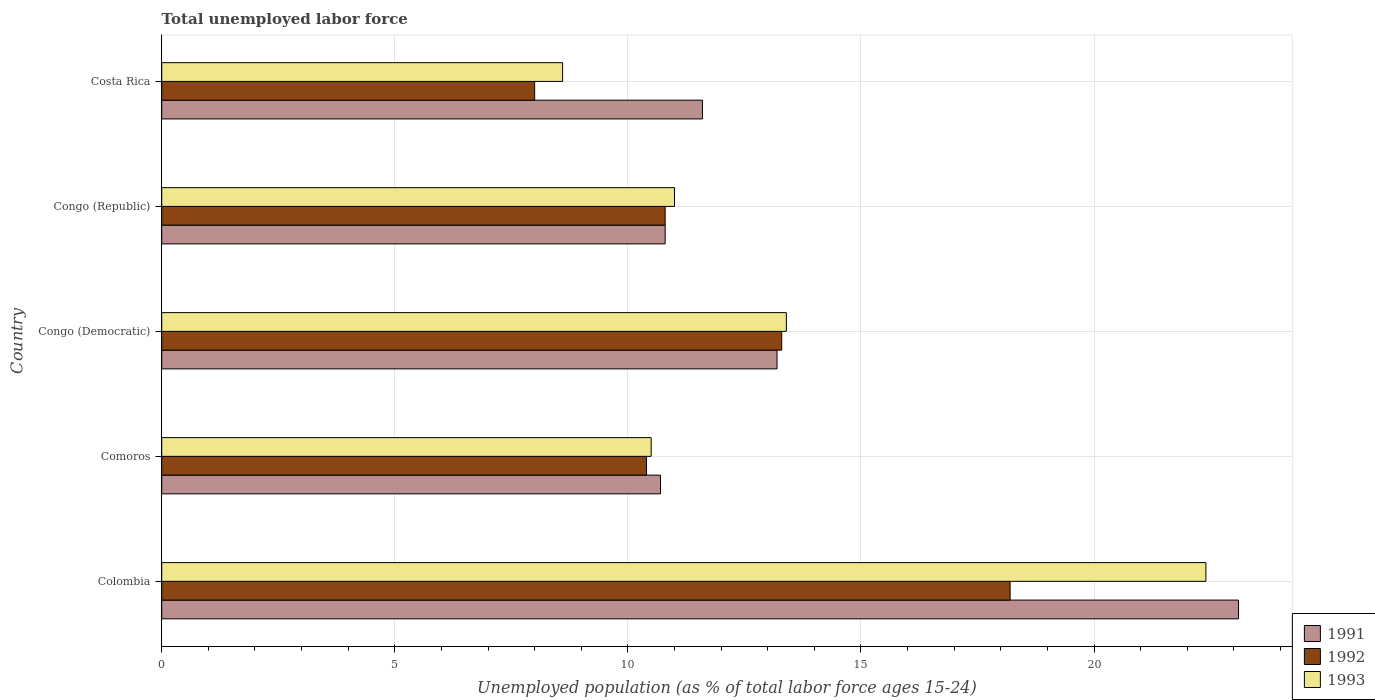How many bars are there on the 4th tick from the top?
Offer a very short reply. 3. How many bars are there on the 5th tick from the bottom?
Offer a very short reply. 3. What is the label of the 4th group of bars from the top?
Make the answer very short. Comoros. In how many cases, is the number of bars for a given country not equal to the number of legend labels?
Keep it short and to the point. 0. What is the percentage of unemployed population in in 1992 in Congo (Democratic)?
Offer a very short reply. 13.3. Across all countries, what is the maximum percentage of unemployed population in in 1992?
Your answer should be very brief. 18.2. In which country was the percentage of unemployed population in in 1991 maximum?
Keep it short and to the point. Colombia. What is the total percentage of unemployed population in in 1992 in the graph?
Make the answer very short. 60.7. What is the difference between the percentage of unemployed population in in 1992 in Congo (Democratic) and that in Congo (Republic)?
Your answer should be very brief. 2.5. What is the difference between the percentage of unemployed population in in 1992 in Comoros and the percentage of unemployed population in in 1991 in Costa Rica?
Offer a very short reply. -1.2. What is the average percentage of unemployed population in in 1991 per country?
Make the answer very short. 13.88. What is the difference between the percentage of unemployed population in in 1993 and percentage of unemployed population in in 1991 in Congo (Republic)?
Give a very brief answer. 0.2. In how many countries, is the percentage of unemployed population in in 1992 greater than 10 %?
Your answer should be very brief. 4. What is the ratio of the percentage of unemployed population in in 1992 in Congo (Democratic) to that in Congo (Republic)?
Keep it short and to the point. 1.23. What is the difference between the highest and the second highest percentage of unemployed population in in 1992?
Offer a very short reply. 4.9. What is the difference between the highest and the lowest percentage of unemployed population in in 1993?
Provide a succinct answer. 13.8. In how many countries, is the percentage of unemployed population in in 1991 greater than the average percentage of unemployed population in in 1991 taken over all countries?
Give a very brief answer. 1. What does the 2nd bar from the bottom in Congo (Democratic) represents?
Give a very brief answer. 1992. Is it the case that in every country, the sum of the percentage of unemployed population in in 1991 and percentage of unemployed population in in 1993 is greater than the percentage of unemployed population in in 1992?
Offer a very short reply. Yes. How many countries are there in the graph?
Provide a short and direct response. 5. Does the graph contain any zero values?
Make the answer very short. No. Does the graph contain grids?
Make the answer very short. Yes. Where does the legend appear in the graph?
Your answer should be very brief. Bottom right. How many legend labels are there?
Your response must be concise. 3. How are the legend labels stacked?
Your answer should be very brief. Vertical. What is the title of the graph?
Give a very brief answer. Total unemployed labor force. What is the label or title of the X-axis?
Provide a short and direct response. Unemployed population (as % of total labor force ages 15-24). What is the label or title of the Y-axis?
Keep it short and to the point. Country. What is the Unemployed population (as % of total labor force ages 15-24) of 1991 in Colombia?
Offer a very short reply. 23.1. What is the Unemployed population (as % of total labor force ages 15-24) in 1992 in Colombia?
Keep it short and to the point. 18.2. What is the Unemployed population (as % of total labor force ages 15-24) of 1993 in Colombia?
Provide a short and direct response. 22.4. What is the Unemployed population (as % of total labor force ages 15-24) in 1991 in Comoros?
Provide a short and direct response. 10.7. What is the Unemployed population (as % of total labor force ages 15-24) in 1992 in Comoros?
Your answer should be very brief. 10.4. What is the Unemployed population (as % of total labor force ages 15-24) in 1993 in Comoros?
Make the answer very short. 10.5. What is the Unemployed population (as % of total labor force ages 15-24) in 1991 in Congo (Democratic)?
Keep it short and to the point. 13.2. What is the Unemployed population (as % of total labor force ages 15-24) of 1992 in Congo (Democratic)?
Offer a very short reply. 13.3. What is the Unemployed population (as % of total labor force ages 15-24) of 1993 in Congo (Democratic)?
Your response must be concise. 13.4. What is the Unemployed population (as % of total labor force ages 15-24) of 1991 in Congo (Republic)?
Make the answer very short. 10.8. What is the Unemployed population (as % of total labor force ages 15-24) in 1992 in Congo (Republic)?
Give a very brief answer. 10.8. What is the Unemployed population (as % of total labor force ages 15-24) in 1991 in Costa Rica?
Your answer should be compact. 11.6. What is the Unemployed population (as % of total labor force ages 15-24) in 1992 in Costa Rica?
Keep it short and to the point. 8. What is the Unemployed population (as % of total labor force ages 15-24) in 1993 in Costa Rica?
Give a very brief answer. 8.6. Across all countries, what is the maximum Unemployed population (as % of total labor force ages 15-24) in 1991?
Your answer should be very brief. 23.1. Across all countries, what is the maximum Unemployed population (as % of total labor force ages 15-24) in 1992?
Ensure brevity in your answer.  18.2. Across all countries, what is the maximum Unemployed population (as % of total labor force ages 15-24) in 1993?
Offer a very short reply. 22.4. Across all countries, what is the minimum Unemployed population (as % of total labor force ages 15-24) of 1991?
Your answer should be very brief. 10.7. Across all countries, what is the minimum Unemployed population (as % of total labor force ages 15-24) in 1993?
Provide a succinct answer. 8.6. What is the total Unemployed population (as % of total labor force ages 15-24) in 1991 in the graph?
Provide a succinct answer. 69.4. What is the total Unemployed population (as % of total labor force ages 15-24) in 1992 in the graph?
Keep it short and to the point. 60.7. What is the total Unemployed population (as % of total labor force ages 15-24) of 1993 in the graph?
Your answer should be compact. 65.9. What is the difference between the Unemployed population (as % of total labor force ages 15-24) of 1993 in Colombia and that in Comoros?
Offer a terse response. 11.9. What is the difference between the Unemployed population (as % of total labor force ages 15-24) in 1991 in Colombia and that in Congo (Democratic)?
Your answer should be compact. 9.9. What is the difference between the Unemployed population (as % of total labor force ages 15-24) of 1992 in Colombia and that in Congo (Democratic)?
Keep it short and to the point. 4.9. What is the difference between the Unemployed population (as % of total labor force ages 15-24) in 1993 in Colombia and that in Congo (Democratic)?
Your response must be concise. 9. What is the difference between the Unemployed population (as % of total labor force ages 15-24) in 1992 in Colombia and that in Congo (Republic)?
Keep it short and to the point. 7.4. What is the difference between the Unemployed population (as % of total labor force ages 15-24) in 1992 in Colombia and that in Costa Rica?
Your answer should be very brief. 10.2. What is the difference between the Unemployed population (as % of total labor force ages 15-24) in 1993 in Colombia and that in Costa Rica?
Provide a short and direct response. 13.8. What is the difference between the Unemployed population (as % of total labor force ages 15-24) of 1993 in Comoros and that in Congo (Democratic)?
Make the answer very short. -2.9. What is the difference between the Unemployed population (as % of total labor force ages 15-24) of 1991 in Comoros and that in Congo (Republic)?
Keep it short and to the point. -0.1. What is the difference between the Unemployed population (as % of total labor force ages 15-24) of 1992 in Comoros and that in Congo (Republic)?
Offer a very short reply. -0.4. What is the difference between the Unemployed population (as % of total labor force ages 15-24) in 1993 in Comoros and that in Congo (Republic)?
Your answer should be compact. -0.5. What is the difference between the Unemployed population (as % of total labor force ages 15-24) in 1991 in Comoros and that in Costa Rica?
Your answer should be very brief. -0.9. What is the difference between the Unemployed population (as % of total labor force ages 15-24) in 1992 in Comoros and that in Costa Rica?
Provide a succinct answer. 2.4. What is the difference between the Unemployed population (as % of total labor force ages 15-24) in 1991 in Congo (Democratic) and that in Congo (Republic)?
Your response must be concise. 2.4. What is the difference between the Unemployed population (as % of total labor force ages 15-24) of 1991 in Colombia and the Unemployed population (as % of total labor force ages 15-24) of 1992 in Comoros?
Your answer should be compact. 12.7. What is the difference between the Unemployed population (as % of total labor force ages 15-24) of 1991 in Colombia and the Unemployed population (as % of total labor force ages 15-24) of 1992 in Congo (Democratic)?
Offer a very short reply. 9.8. What is the difference between the Unemployed population (as % of total labor force ages 15-24) of 1991 in Colombia and the Unemployed population (as % of total labor force ages 15-24) of 1993 in Congo (Democratic)?
Keep it short and to the point. 9.7. What is the difference between the Unemployed population (as % of total labor force ages 15-24) of 1991 in Colombia and the Unemployed population (as % of total labor force ages 15-24) of 1992 in Congo (Republic)?
Make the answer very short. 12.3. What is the difference between the Unemployed population (as % of total labor force ages 15-24) of 1991 in Colombia and the Unemployed population (as % of total labor force ages 15-24) of 1993 in Congo (Republic)?
Offer a very short reply. 12.1. What is the difference between the Unemployed population (as % of total labor force ages 15-24) of 1991 in Colombia and the Unemployed population (as % of total labor force ages 15-24) of 1992 in Costa Rica?
Your answer should be compact. 15.1. What is the difference between the Unemployed population (as % of total labor force ages 15-24) in 1991 in Colombia and the Unemployed population (as % of total labor force ages 15-24) in 1993 in Costa Rica?
Offer a very short reply. 14.5. What is the difference between the Unemployed population (as % of total labor force ages 15-24) in 1991 in Comoros and the Unemployed population (as % of total labor force ages 15-24) in 1992 in Congo (Democratic)?
Provide a short and direct response. -2.6. What is the difference between the Unemployed population (as % of total labor force ages 15-24) of 1991 in Comoros and the Unemployed population (as % of total labor force ages 15-24) of 1993 in Congo (Democratic)?
Your answer should be compact. -2.7. What is the difference between the Unemployed population (as % of total labor force ages 15-24) in 1992 in Comoros and the Unemployed population (as % of total labor force ages 15-24) in 1993 in Congo (Democratic)?
Your answer should be compact. -3. What is the difference between the Unemployed population (as % of total labor force ages 15-24) in 1991 in Comoros and the Unemployed population (as % of total labor force ages 15-24) in 1992 in Congo (Republic)?
Your response must be concise. -0.1. What is the difference between the Unemployed population (as % of total labor force ages 15-24) in 1991 in Comoros and the Unemployed population (as % of total labor force ages 15-24) in 1993 in Congo (Republic)?
Ensure brevity in your answer.  -0.3. What is the difference between the Unemployed population (as % of total labor force ages 15-24) in 1991 in Comoros and the Unemployed population (as % of total labor force ages 15-24) in 1993 in Costa Rica?
Provide a short and direct response. 2.1. What is the difference between the Unemployed population (as % of total labor force ages 15-24) of 1991 in Congo (Democratic) and the Unemployed population (as % of total labor force ages 15-24) of 1993 in Congo (Republic)?
Ensure brevity in your answer.  2.2. What is the difference between the Unemployed population (as % of total labor force ages 15-24) of 1991 in Congo (Democratic) and the Unemployed population (as % of total labor force ages 15-24) of 1992 in Costa Rica?
Provide a short and direct response. 5.2. What is the average Unemployed population (as % of total labor force ages 15-24) in 1991 per country?
Your response must be concise. 13.88. What is the average Unemployed population (as % of total labor force ages 15-24) in 1992 per country?
Your answer should be very brief. 12.14. What is the average Unemployed population (as % of total labor force ages 15-24) in 1993 per country?
Give a very brief answer. 13.18. What is the difference between the Unemployed population (as % of total labor force ages 15-24) in 1991 and Unemployed population (as % of total labor force ages 15-24) in 1992 in Colombia?
Your answer should be very brief. 4.9. What is the difference between the Unemployed population (as % of total labor force ages 15-24) in 1992 and Unemployed population (as % of total labor force ages 15-24) in 1993 in Colombia?
Your answer should be very brief. -4.2. What is the difference between the Unemployed population (as % of total labor force ages 15-24) in 1991 and Unemployed population (as % of total labor force ages 15-24) in 1992 in Comoros?
Ensure brevity in your answer.  0.3. What is the difference between the Unemployed population (as % of total labor force ages 15-24) of 1991 and Unemployed population (as % of total labor force ages 15-24) of 1993 in Comoros?
Keep it short and to the point. 0.2. What is the difference between the Unemployed population (as % of total labor force ages 15-24) in 1991 and Unemployed population (as % of total labor force ages 15-24) in 1992 in Congo (Democratic)?
Offer a terse response. -0.1. What is the difference between the Unemployed population (as % of total labor force ages 15-24) of 1991 and Unemployed population (as % of total labor force ages 15-24) of 1993 in Congo (Democratic)?
Provide a short and direct response. -0.2. What is the difference between the Unemployed population (as % of total labor force ages 15-24) of 1992 and Unemployed population (as % of total labor force ages 15-24) of 1993 in Congo (Democratic)?
Your answer should be very brief. -0.1. What is the difference between the Unemployed population (as % of total labor force ages 15-24) of 1991 and Unemployed population (as % of total labor force ages 15-24) of 1992 in Congo (Republic)?
Provide a short and direct response. 0. What is the difference between the Unemployed population (as % of total labor force ages 15-24) of 1991 and Unemployed population (as % of total labor force ages 15-24) of 1993 in Congo (Republic)?
Provide a short and direct response. -0.2. What is the difference between the Unemployed population (as % of total labor force ages 15-24) of 1992 and Unemployed population (as % of total labor force ages 15-24) of 1993 in Congo (Republic)?
Offer a very short reply. -0.2. What is the difference between the Unemployed population (as % of total labor force ages 15-24) in 1991 and Unemployed population (as % of total labor force ages 15-24) in 1993 in Costa Rica?
Provide a short and direct response. 3. What is the ratio of the Unemployed population (as % of total labor force ages 15-24) of 1991 in Colombia to that in Comoros?
Make the answer very short. 2.16. What is the ratio of the Unemployed population (as % of total labor force ages 15-24) in 1992 in Colombia to that in Comoros?
Provide a succinct answer. 1.75. What is the ratio of the Unemployed population (as % of total labor force ages 15-24) in 1993 in Colombia to that in Comoros?
Your response must be concise. 2.13. What is the ratio of the Unemployed population (as % of total labor force ages 15-24) of 1992 in Colombia to that in Congo (Democratic)?
Ensure brevity in your answer.  1.37. What is the ratio of the Unemployed population (as % of total labor force ages 15-24) of 1993 in Colombia to that in Congo (Democratic)?
Keep it short and to the point. 1.67. What is the ratio of the Unemployed population (as % of total labor force ages 15-24) of 1991 in Colombia to that in Congo (Republic)?
Offer a terse response. 2.14. What is the ratio of the Unemployed population (as % of total labor force ages 15-24) of 1992 in Colombia to that in Congo (Republic)?
Provide a short and direct response. 1.69. What is the ratio of the Unemployed population (as % of total labor force ages 15-24) in 1993 in Colombia to that in Congo (Republic)?
Offer a very short reply. 2.04. What is the ratio of the Unemployed population (as % of total labor force ages 15-24) of 1991 in Colombia to that in Costa Rica?
Your answer should be compact. 1.99. What is the ratio of the Unemployed population (as % of total labor force ages 15-24) of 1992 in Colombia to that in Costa Rica?
Keep it short and to the point. 2.27. What is the ratio of the Unemployed population (as % of total labor force ages 15-24) in 1993 in Colombia to that in Costa Rica?
Keep it short and to the point. 2.6. What is the ratio of the Unemployed population (as % of total labor force ages 15-24) of 1991 in Comoros to that in Congo (Democratic)?
Offer a terse response. 0.81. What is the ratio of the Unemployed population (as % of total labor force ages 15-24) in 1992 in Comoros to that in Congo (Democratic)?
Your answer should be compact. 0.78. What is the ratio of the Unemployed population (as % of total labor force ages 15-24) of 1993 in Comoros to that in Congo (Democratic)?
Keep it short and to the point. 0.78. What is the ratio of the Unemployed population (as % of total labor force ages 15-24) of 1993 in Comoros to that in Congo (Republic)?
Your answer should be very brief. 0.95. What is the ratio of the Unemployed population (as % of total labor force ages 15-24) of 1991 in Comoros to that in Costa Rica?
Ensure brevity in your answer.  0.92. What is the ratio of the Unemployed population (as % of total labor force ages 15-24) of 1992 in Comoros to that in Costa Rica?
Keep it short and to the point. 1.3. What is the ratio of the Unemployed population (as % of total labor force ages 15-24) of 1993 in Comoros to that in Costa Rica?
Provide a short and direct response. 1.22. What is the ratio of the Unemployed population (as % of total labor force ages 15-24) of 1991 in Congo (Democratic) to that in Congo (Republic)?
Your response must be concise. 1.22. What is the ratio of the Unemployed population (as % of total labor force ages 15-24) in 1992 in Congo (Democratic) to that in Congo (Republic)?
Ensure brevity in your answer.  1.23. What is the ratio of the Unemployed population (as % of total labor force ages 15-24) in 1993 in Congo (Democratic) to that in Congo (Republic)?
Your answer should be very brief. 1.22. What is the ratio of the Unemployed population (as % of total labor force ages 15-24) of 1991 in Congo (Democratic) to that in Costa Rica?
Your answer should be compact. 1.14. What is the ratio of the Unemployed population (as % of total labor force ages 15-24) of 1992 in Congo (Democratic) to that in Costa Rica?
Your answer should be very brief. 1.66. What is the ratio of the Unemployed population (as % of total labor force ages 15-24) in 1993 in Congo (Democratic) to that in Costa Rica?
Keep it short and to the point. 1.56. What is the ratio of the Unemployed population (as % of total labor force ages 15-24) of 1992 in Congo (Republic) to that in Costa Rica?
Offer a terse response. 1.35. What is the ratio of the Unemployed population (as % of total labor force ages 15-24) of 1993 in Congo (Republic) to that in Costa Rica?
Ensure brevity in your answer.  1.28. What is the difference between the highest and the second highest Unemployed population (as % of total labor force ages 15-24) of 1992?
Make the answer very short. 4.9. What is the difference between the highest and the lowest Unemployed population (as % of total labor force ages 15-24) in 1992?
Your response must be concise. 10.2. 